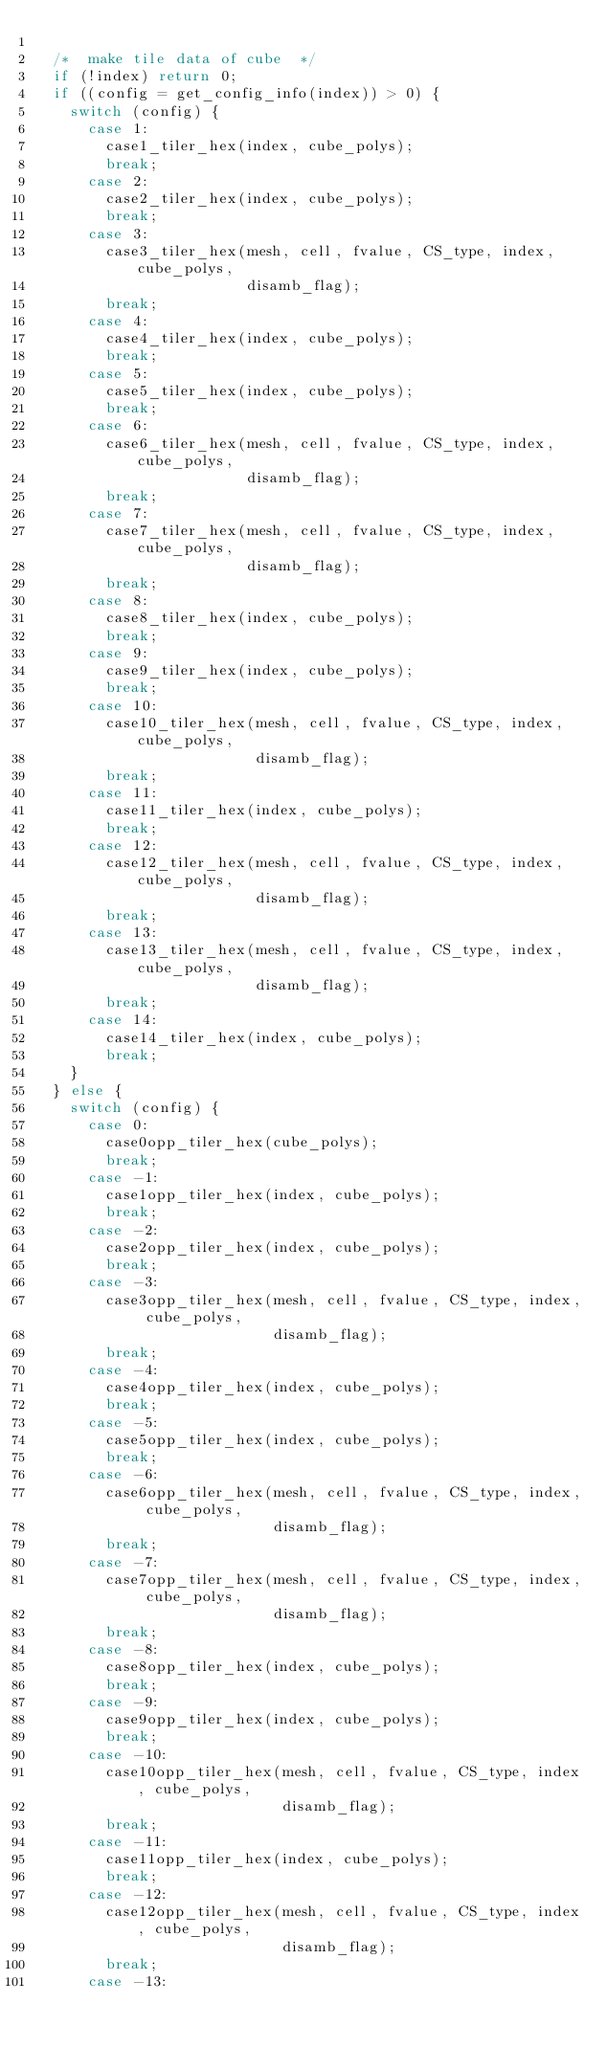<code> <loc_0><loc_0><loc_500><loc_500><_C_>
  /*  make tile data of cube  */
  if (!index) return 0;
  if ((config = get_config_info(index)) > 0) {
    switch (config) {
      case 1:
        case1_tiler_hex(index, cube_polys);
        break;
      case 2:
        case2_tiler_hex(index, cube_polys);
        break;
      case 3:
        case3_tiler_hex(mesh, cell, fvalue, CS_type, index, cube_polys,
                        disamb_flag);
        break;
      case 4:
        case4_tiler_hex(index, cube_polys);
        break;
      case 5:
        case5_tiler_hex(index, cube_polys);
        break;
      case 6:
        case6_tiler_hex(mesh, cell, fvalue, CS_type, index, cube_polys,
                        disamb_flag);
        break;
      case 7:
        case7_tiler_hex(mesh, cell, fvalue, CS_type, index, cube_polys,
                        disamb_flag);
        break;
      case 8:
        case8_tiler_hex(index, cube_polys);
        break;
      case 9:
        case9_tiler_hex(index, cube_polys);
        break;
      case 10:
        case10_tiler_hex(mesh, cell, fvalue, CS_type, index, cube_polys,
                         disamb_flag);
        break;
      case 11:
        case11_tiler_hex(index, cube_polys);
        break;
      case 12:
        case12_tiler_hex(mesh, cell, fvalue, CS_type, index, cube_polys,
                         disamb_flag);
        break;
      case 13:
        case13_tiler_hex(mesh, cell, fvalue, CS_type, index, cube_polys,
                         disamb_flag);
        break;
      case 14:
        case14_tiler_hex(index, cube_polys);
        break;
    }
  } else {
    switch (config) {
      case 0:
        case0opp_tiler_hex(cube_polys);
        break;
      case -1:
        case1opp_tiler_hex(index, cube_polys);
        break;
      case -2:
        case2opp_tiler_hex(index, cube_polys);
        break;
      case -3:
        case3opp_tiler_hex(mesh, cell, fvalue, CS_type, index, cube_polys,
                           disamb_flag);
        break;
      case -4:
        case4opp_tiler_hex(index, cube_polys);
        break;
      case -5:
        case5opp_tiler_hex(index, cube_polys);
        break;
      case -6:
        case6opp_tiler_hex(mesh, cell, fvalue, CS_type, index, cube_polys,
                           disamb_flag);
        break;
      case -7:
        case7opp_tiler_hex(mesh, cell, fvalue, CS_type, index, cube_polys,
                           disamb_flag);
        break;
      case -8:
        case8opp_tiler_hex(index, cube_polys);
        break;
      case -9:
        case9opp_tiler_hex(index, cube_polys);
        break;
      case -10:
        case10opp_tiler_hex(mesh, cell, fvalue, CS_type, index, cube_polys,
                            disamb_flag);
        break;
      case -11:
        case11opp_tiler_hex(index, cube_polys);
        break;
      case -12:
        case12opp_tiler_hex(mesh, cell, fvalue, CS_type, index, cube_polys,
                            disamb_flag);
        break;
      case -13:</code> 